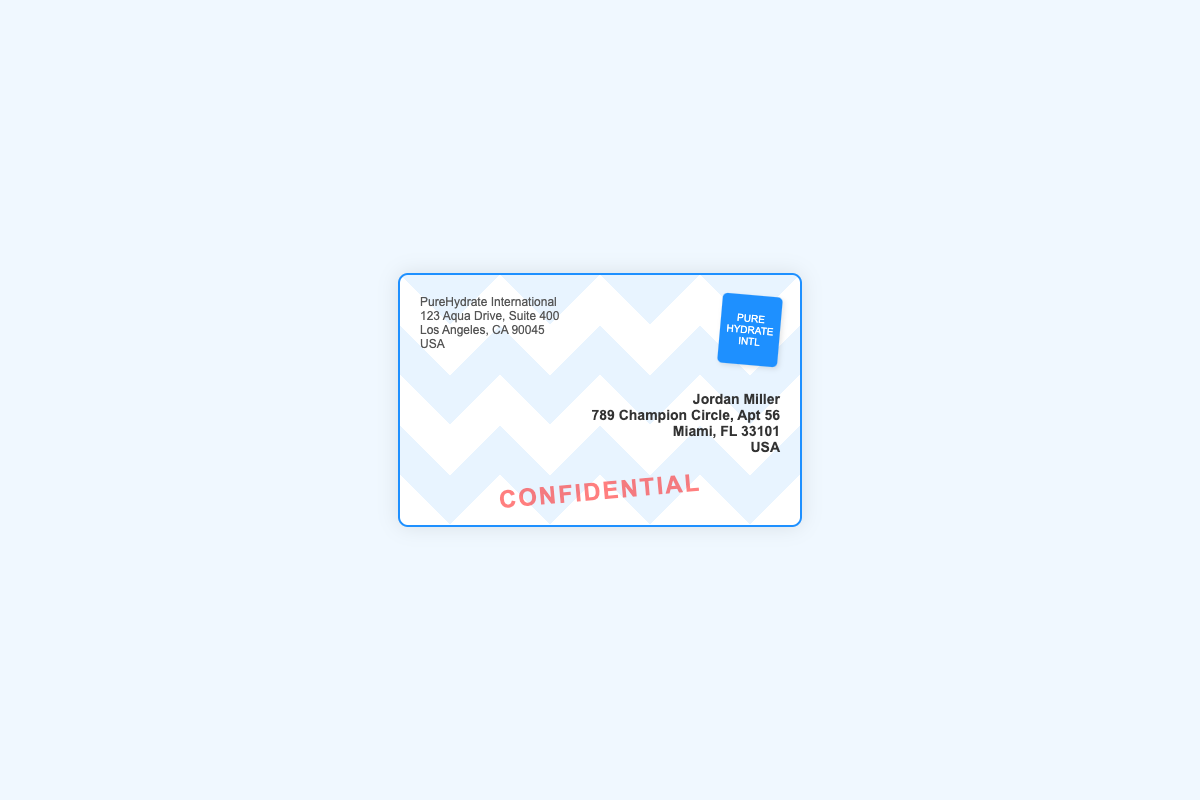What is the sender's company name? The sender's company name is listed at the top left of the envelope.
Answer: PureHydrate International What is the sender's street address? The sender's street address is found below their company name.
Answer: 123 Aqua Drive, Suite 400 What is the recipient's name? The recipient's name is prominently displayed on the right side of the envelope.
Answer: Jordan Miller What is the recipient's city? The recipient's city is part of their address provided on the right side.
Answer: Miami Which state is the sender located in? The state of the sender's address can be found in the details provided.
Answer: CA What is the ZIP code of the recipient's address? The ZIP code is part of the recipient's address mentioned in the document.
Answer: 33101 What is the country of the sender? The country is stated at the bottom of the sender's address.
Answer: USA What is the primary color of the envelope's design? The primary color of the envelope's design can be observed throughout the visual style.
Answer: Blue What does the stamp on the envelope say? The stamp details can be seen in the top right corner of the envelope.
Answer: PURE HYDRATE INTL 